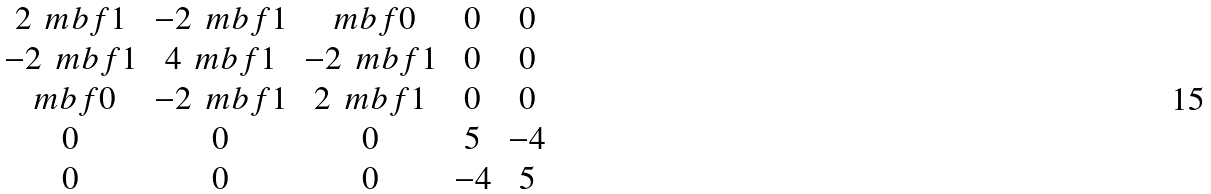<formula> <loc_0><loc_0><loc_500><loc_500>\begin{matrix} 2 \, { \ m b f 1 } & - 2 \, { \ m b f 1 } & { \ m b f 0 } & 0 & 0 \\ - 2 \, { \ m b f 1 } & 4 \, { \ m b f 1 } & - 2 \, { \ m b f 1 } & 0 & 0 \\ { \ m b f 0 } & - 2 \, { \ m b f 1 } & 2 \, { \ m b f 1 } & 0 & 0 \\ 0 & 0 & 0 & 5 & - 4 \\ 0 & 0 & 0 & - 4 & 5 \\ \end{matrix}</formula> 